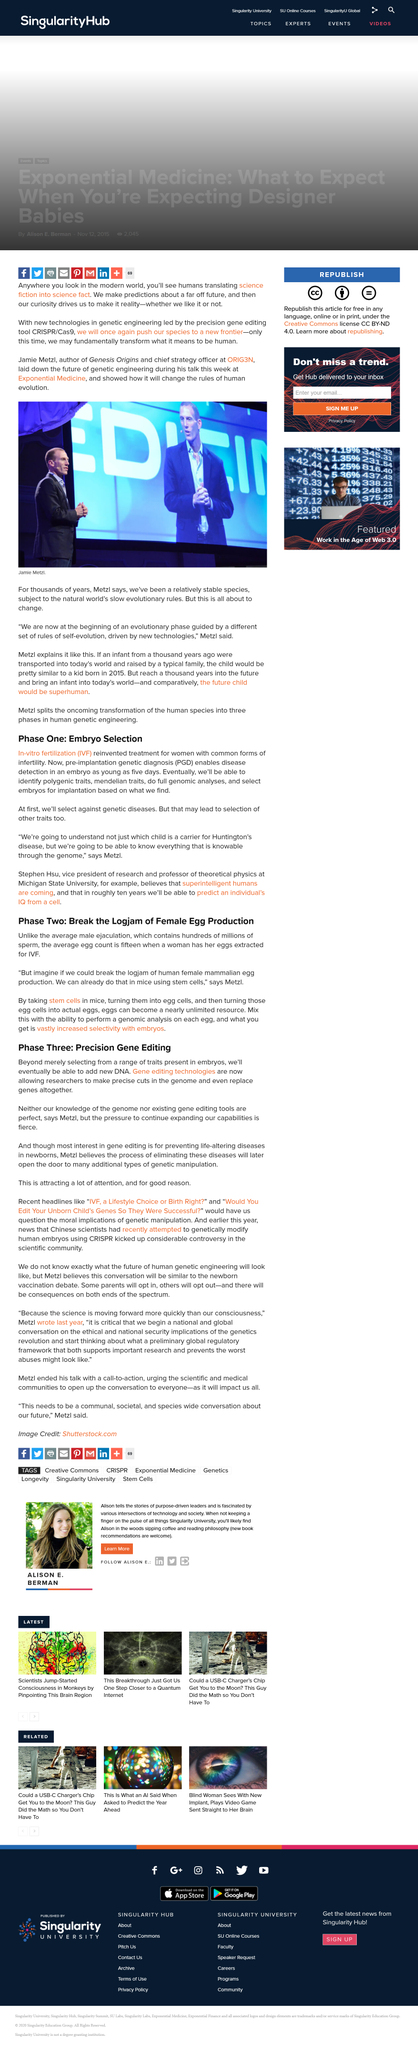Mention a couple of crucial points in this snapshot. Jamie Metzl is the author of Genesis Origins. The average number of eggs extracted from a woman undergoing in vitro fertilization (IVF) is approximately fifteen. The picture is of a person named Jamie Metzl. The average male ejaculation contains a significant quantity of sperm, with hundreds of millions of sperm present. Stephen Hsu is a professor at Michigan State University. 